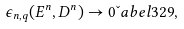<formula> <loc_0><loc_0><loc_500><loc_500>\epsilon _ { n , q } ( { E } ^ { n } , { D } ^ { n } ) \to 0 \L a b e l { 3 2 9 } ,</formula> 